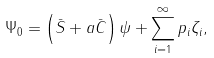<formula> <loc_0><loc_0><loc_500><loc_500>\Psi _ { 0 } = \left ( \bar { S } + a \bar { C } \right ) \psi + \sum _ { i = 1 } ^ { \infty } p _ { i } \zeta _ { i } ,</formula> 